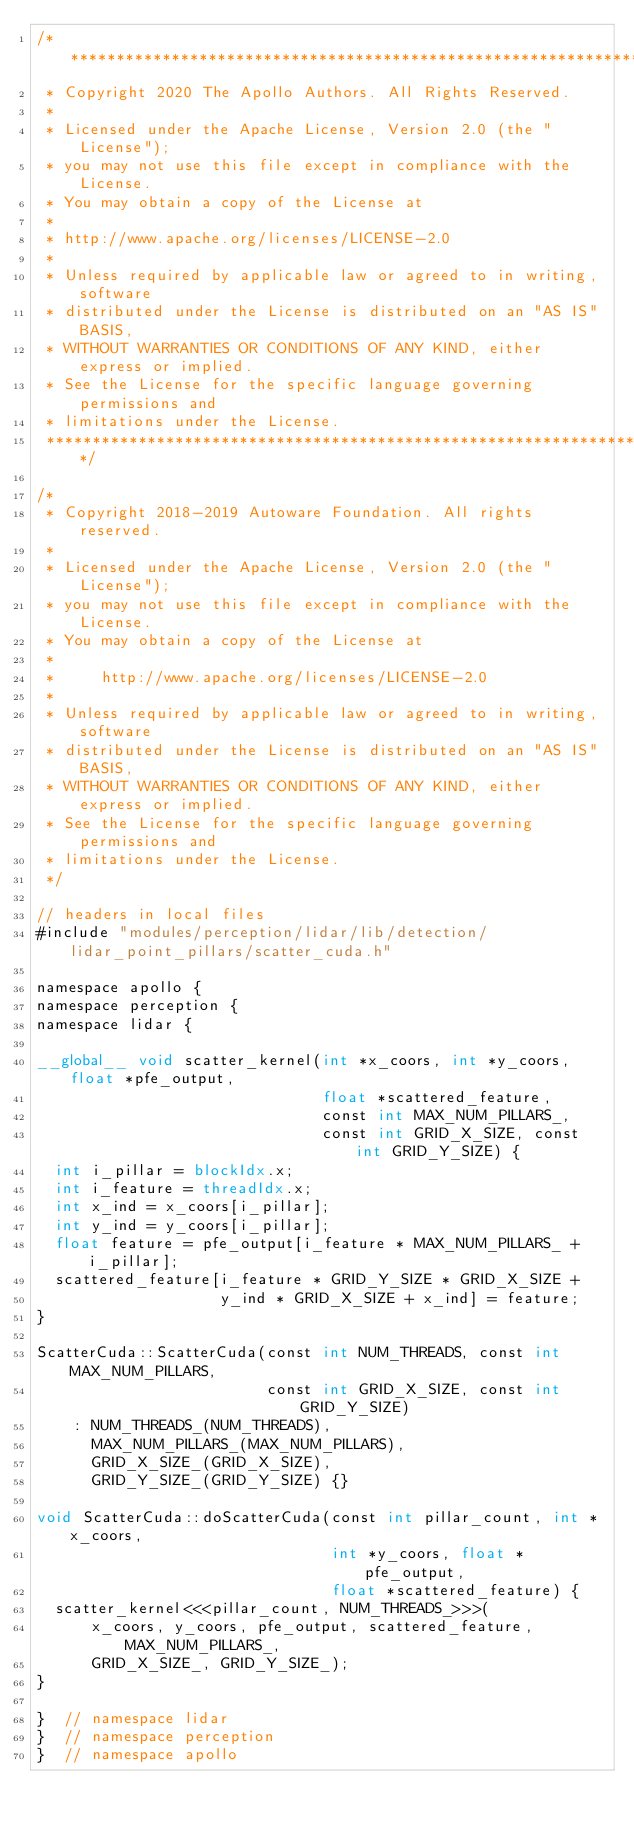<code> <loc_0><loc_0><loc_500><loc_500><_Cuda_>/******************************************************************************
 * Copyright 2020 The Apollo Authors. All Rights Reserved.
 *
 * Licensed under the Apache License, Version 2.0 (the "License");
 * you may not use this file except in compliance with the License.
 * You may obtain a copy of the License at
 *
 * http://www.apache.org/licenses/LICENSE-2.0
 *
 * Unless required by applicable law or agreed to in writing, software
 * distributed under the License is distributed on an "AS IS" BASIS,
 * WITHOUT WARRANTIES OR CONDITIONS OF ANY KIND, either express or implied.
 * See the License for the specific language governing permissions and
 * limitations under the License.
 *****************************************************************************/

/*
 * Copyright 2018-2019 Autoware Foundation. All rights reserved.
 *
 * Licensed under the Apache License, Version 2.0 (the "License");
 * you may not use this file except in compliance with the License.
 * You may obtain a copy of the License at
 *
 *     http://www.apache.org/licenses/LICENSE-2.0
 *
 * Unless required by applicable law or agreed to in writing, software
 * distributed under the License is distributed on an "AS IS" BASIS,
 * WITHOUT WARRANTIES OR CONDITIONS OF ANY KIND, either express or implied.
 * See the License for the specific language governing permissions and
 * limitations under the License.
 */

// headers in local files
#include "modules/perception/lidar/lib/detection/lidar_point_pillars/scatter_cuda.h"

namespace apollo {
namespace perception {
namespace lidar {

__global__ void scatter_kernel(int *x_coors, int *y_coors, float *pfe_output,
                               float *scattered_feature,
                               const int MAX_NUM_PILLARS_,
                               const int GRID_X_SIZE, const int GRID_Y_SIZE) {
  int i_pillar = blockIdx.x;
  int i_feature = threadIdx.x;
  int x_ind = x_coors[i_pillar];
  int y_ind = y_coors[i_pillar];
  float feature = pfe_output[i_feature * MAX_NUM_PILLARS_ + i_pillar];
  scattered_feature[i_feature * GRID_Y_SIZE * GRID_X_SIZE +
                    y_ind * GRID_X_SIZE + x_ind] = feature;
}

ScatterCuda::ScatterCuda(const int NUM_THREADS, const int MAX_NUM_PILLARS,
                         const int GRID_X_SIZE, const int GRID_Y_SIZE)
    : NUM_THREADS_(NUM_THREADS),
      MAX_NUM_PILLARS_(MAX_NUM_PILLARS),
      GRID_X_SIZE_(GRID_X_SIZE),
      GRID_Y_SIZE_(GRID_Y_SIZE) {}

void ScatterCuda::doScatterCuda(const int pillar_count, int *x_coors,
                                int *y_coors, float *pfe_output,
                                float *scattered_feature) {
  scatter_kernel<<<pillar_count, NUM_THREADS_>>>(
      x_coors, y_coors, pfe_output, scattered_feature, MAX_NUM_PILLARS_,
      GRID_X_SIZE_, GRID_Y_SIZE_);
}

}  // namespace lidar
}  // namespace perception
}  // namespace apollo
</code> 